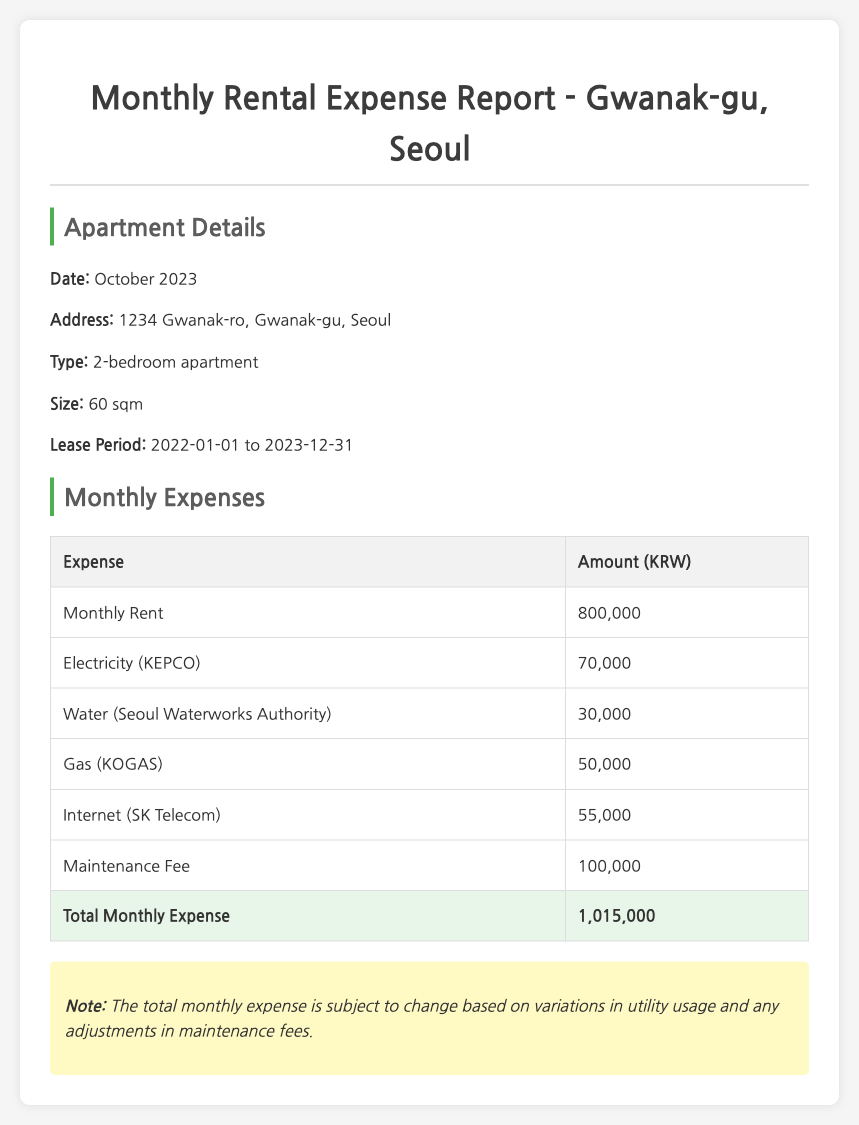What is the total monthly expense? The total monthly expense is the sum of all expenses listed in the document, which amounts to 800,000 + 70,000 + 30,000 + 50,000 + 55,000 + 100,000 = 1,015,000.
Answer: 1,015,000 What is the date of the report? The date of the report is explicitly mentioned in the apartment details section of the document.
Answer: October 2023 How much is the maintenance fee? The maintenance fee is one of the entries in the monthly expenses table.
Answer: 100,000 What is the address of the apartment? The address of the apartment is provided in the apartment details section of the document.
Answer: 1234 Gwanak-ro, Gwanak-gu, Seoul What type of apartment is listed in the report? The document specifies the type of the apartment in the apartment details section.
Answer: 2-bedroom apartment What utility expense has the highest amount? By comparing the expense amounts listed, we can identify which utility charge is the highest.
Answer: Electricity Is the reporting period of the lease mentioned in the document? The lease period is stated in the apartment details section, indicating the duration of the rental agreement.
Answer: 2022-01-01 to 2023-12-31 What amount is charged for gas? The gas fee is clearly stated as one of the components of the monthly expenses.
Answer: 50,000 What note is included in the report? The note provides additional context regarding the total monthly expense and its variability.
Answer: The total monthly expense is subject to change based on variations in utility usage and any adjustments in maintenance fees 